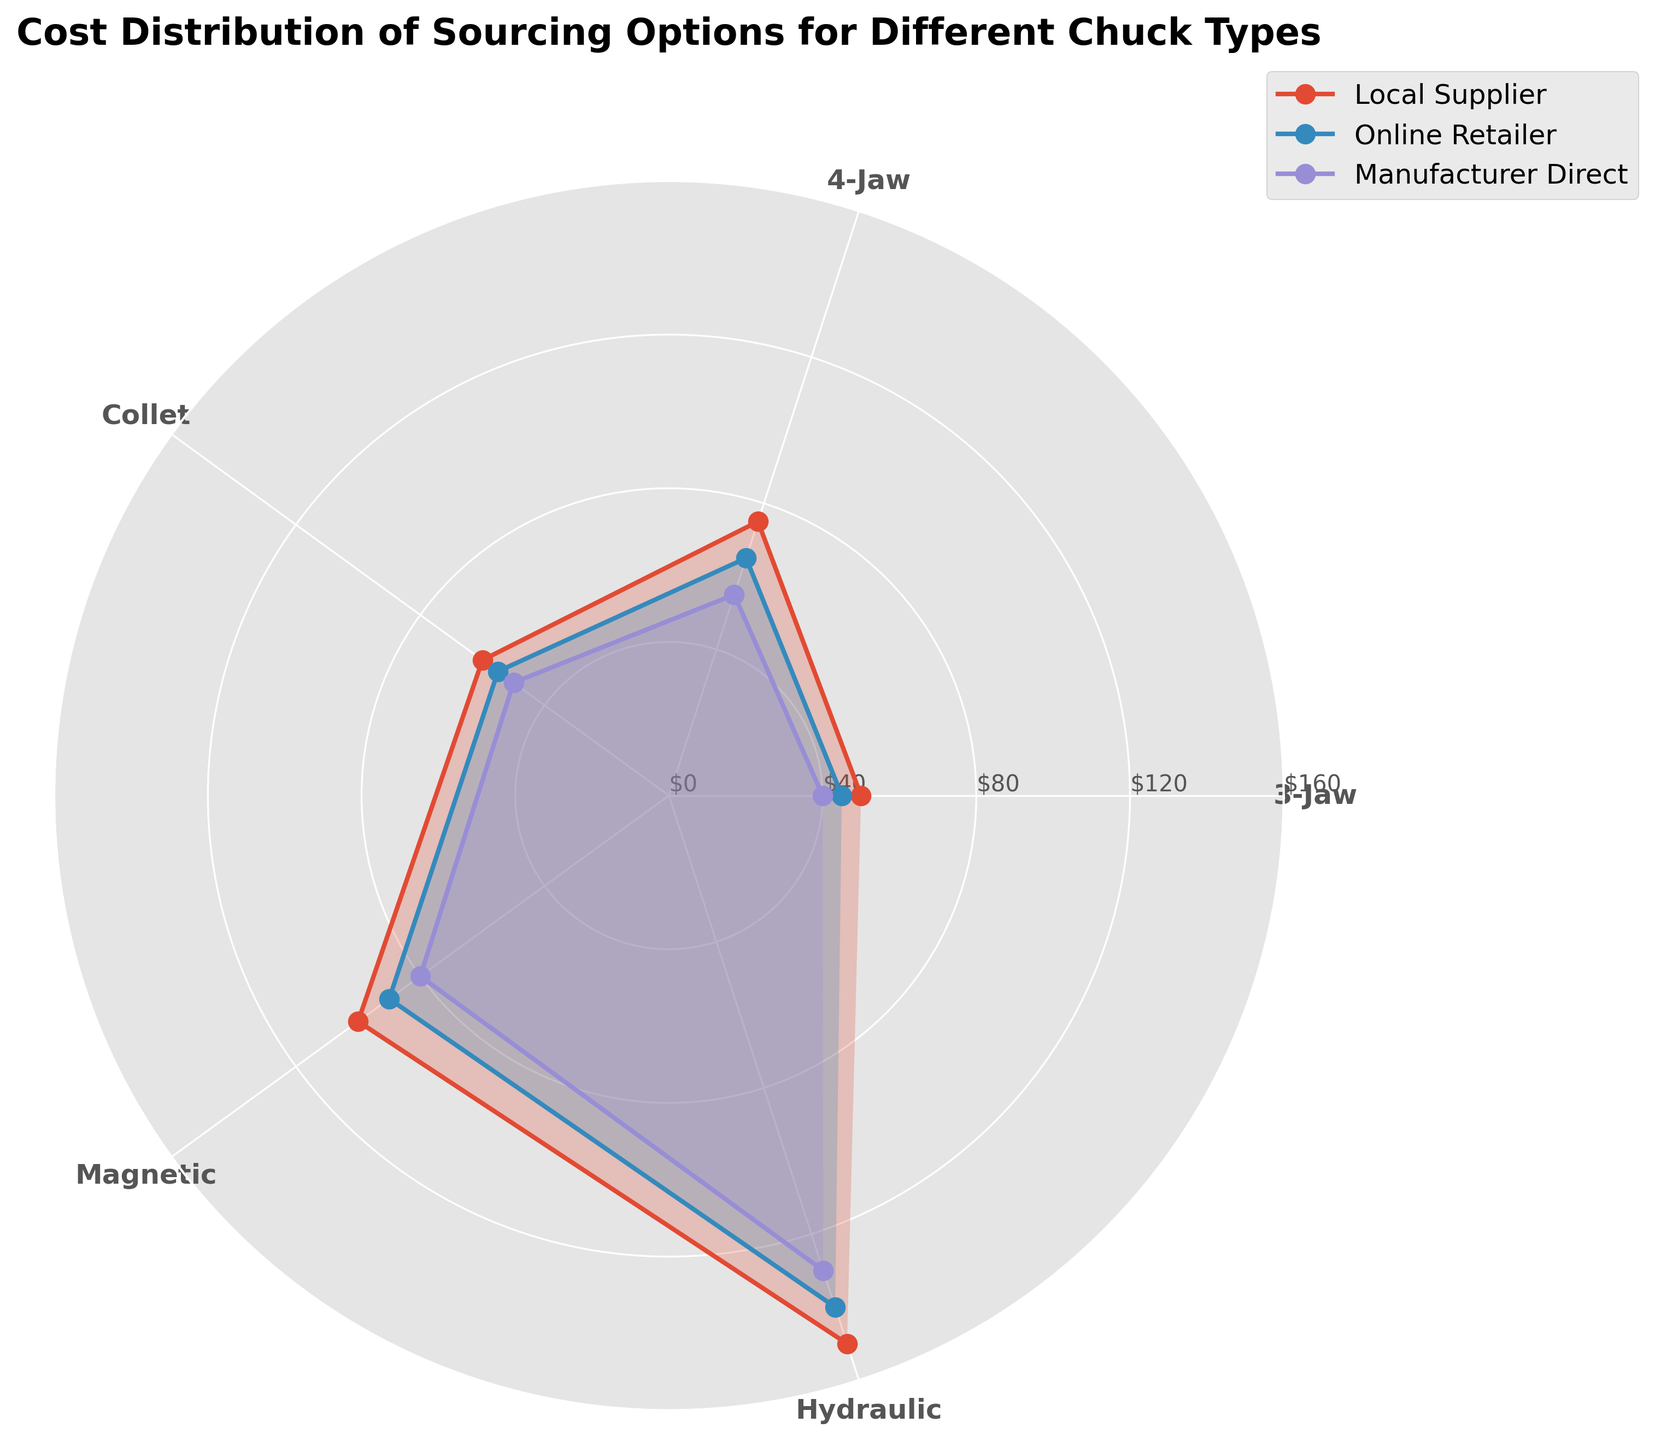what is the title of the plot? The plot's title is located at the top center, describing the main focus of the visual representation.
Answer: Cost Distribution of Sourcing Options for Different Chuck Types how many different chuck types are displayed in the plot? By examining the angle ticks labeled around the plot, we can see that there are distinct labels representing chuck types. Count these labels to determine the number of chuck types.
Answer: 5 what is the cost range for "Manufacturer Direct" suppliers across all chuck types? To identify the cost range, look at the radial distance of the points corresponding to "Manufacturer Direct" from the center of the plot (indicated by the legend). The lowest value appears for "3-Jaw," and the highest for "Hydraulic."
Answer: $40 to $130 which supplier offers the lowest cost for the "Hydraulic" chuck type? Examine the radial positions of the points labeled "Hydraulic" for each supplier (indicated by different marker styles/colors). The supplier closest to the center offers the lowest cost.
Answer: Manufacturer Direct compare the costs for "4-Jaw" chuck type between the local supplier and online retailer. Which one is cheaper and by how much? Look at the radial positions for the points labeled "4-Jaw." Find the points corresponding to "Local Supplier" and "Online Retailer" (using the legend for marker/color reference). Compare their costs and calculate the difference.
Answer: Online Retailer is cheaper by $10 what is the average cost of all suppliers for the "3-Jaw" chuck type? Identify the costs for "3-Jaw" from Local Supplier, Online Retailer, and Manufacturer Direct. Sum these values and divide by the number of suppliers.
Answer: $45 which chuck type has the highest overall cost across all suppliers? Identify the maximum radial distance (or cost) for each chuck type and compare them. The chuck type with the highest value has the highest overall cost.
Answer: Hydraulic is the cost distribution for "Collet" chuck type relatively uniform across suppliers compared to "Magnetic"? Compare the radial distances for "Collet" and "Magnetic" across all suppliers. Note the variability (how spread out or close together the points are).
Answer: Yes, the costs for "Collet" are more uniform what is the difference in cost between "Local Supplier" and "Manufacturer Direct" for the "Magnetic" chuck type? Identify the radial distances for "Local Supplier" and "Manufacturer Direct" at the "Magnetic" label. Subtract the "Manufacturer Direct" cost from the "Local Supplier" cost.
Answer: $20 which supplier has the most significant cost variability across all chuck types? Examine the radial spread for each supplier (observing how far their points are spread along the radius). The supplier with the widest spread has the most significant variability.
Answer: Local Supplier 